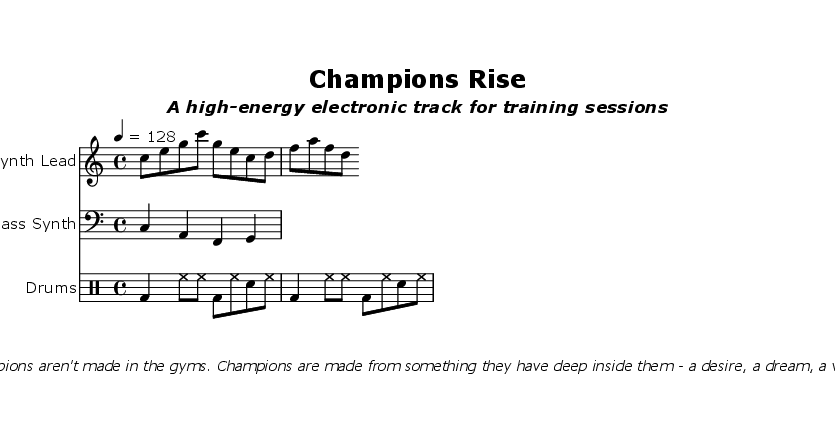What is the key signature of this music? The key signature is indicated by the section before the music begins, which shows no sharps or flats. C major has no accidentals in its key signature.
Answer: C major What is the time signature of this music? The time signature is also located at the beginning of the music. It shows a "4/4" which signifies four beats in each measure.
Answer: 4/4 What is the tempo marking of this piece? The tempo marking is provided in beats per minute (BPM) and is indicated at the start with a "4 = 128". This means the quarter note is played at 128 BPM.
Answer: 128 How many measures do the drum patterns consist of? The drum patterns can be counted by identifying their structure in the code, which shows two repetitions of the written pattern, indicating two measures are repeated.
Answer: 2 Which instrument plays the lead melody? The instrument that plays the lead melody is identified at the top of the corresponding staff. It is titled "Synth Lead," indicating it is performed by the synthesizer.
Answer: Synth Lead What motivational quote is included in the sheet music? The quote is presented in the markup section and is distinctly italicized. It states that champions are made from a deep desire, a dream, and a vision, which serves as motivation.
Answer: "Champions aren't made in the gyms. Champions are made from something they have deep inside them - a desire, a dream, a vision." 